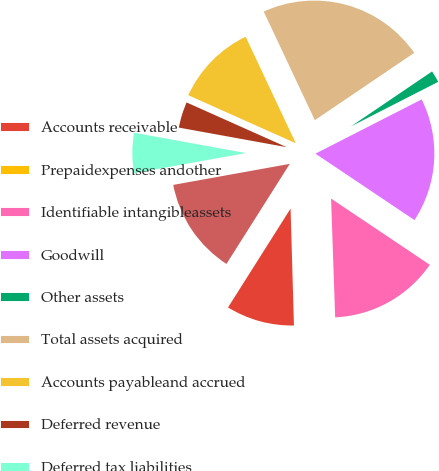Convert chart to OTSL. <chart><loc_0><loc_0><loc_500><loc_500><pie_chart><fcel>Accounts receivable<fcel>Prepaidexpenses andother<fcel>Identifiable intangibleassets<fcel>Goodwill<fcel>Other assets<fcel>Total assets acquired<fcel>Accounts payableand accrued<fcel>Deferred revenue<fcel>Deferred tax liabilities<fcel>Total liabilitiesacquired<nl><fcel>9.44%<fcel>0.09%<fcel>15.05%<fcel>16.92%<fcel>1.96%<fcel>22.53%<fcel>11.31%<fcel>3.83%<fcel>5.7%<fcel>13.18%<nl></chart> 